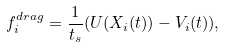<formula> <loc_0><loc_0><loc_500><loc_500>f ^ { d r a g } _ { i } = \frac { 1 } { t _ { s } } ( U ( X _ { i } ( t ) ) - V _ { i } ( t ) ) ,</formula> 